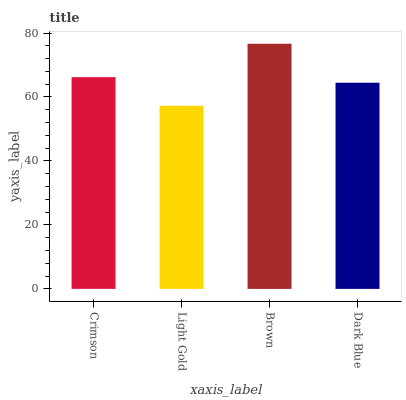Is Light Gold the minimum?
Answer yes or no. Yes. Is Brown the maximum?
Answer yes or no. Yes. Is Brown the minimum?
Answer yes or no. No. Is Light Gold the maximum?
Answer yes or no. No. Is Brown greater than Light Gold?
Answer yes or no. Yes. Is Light Gold less than Brown?
Answer yes or no. Yes. Is Light Gold greater than Brown?
Answer yes or no. No. Is Brown less than Light Gold?
Answer yes or no. No. Is Crimson the high median?
Answer yes or no. Yes. Is Dark Blue the low median?
Answer yes or no. Yes. Is Brown the high median?
Answer yes or no. No. Is Light Gold the low median?
Answer yes or no. No. 